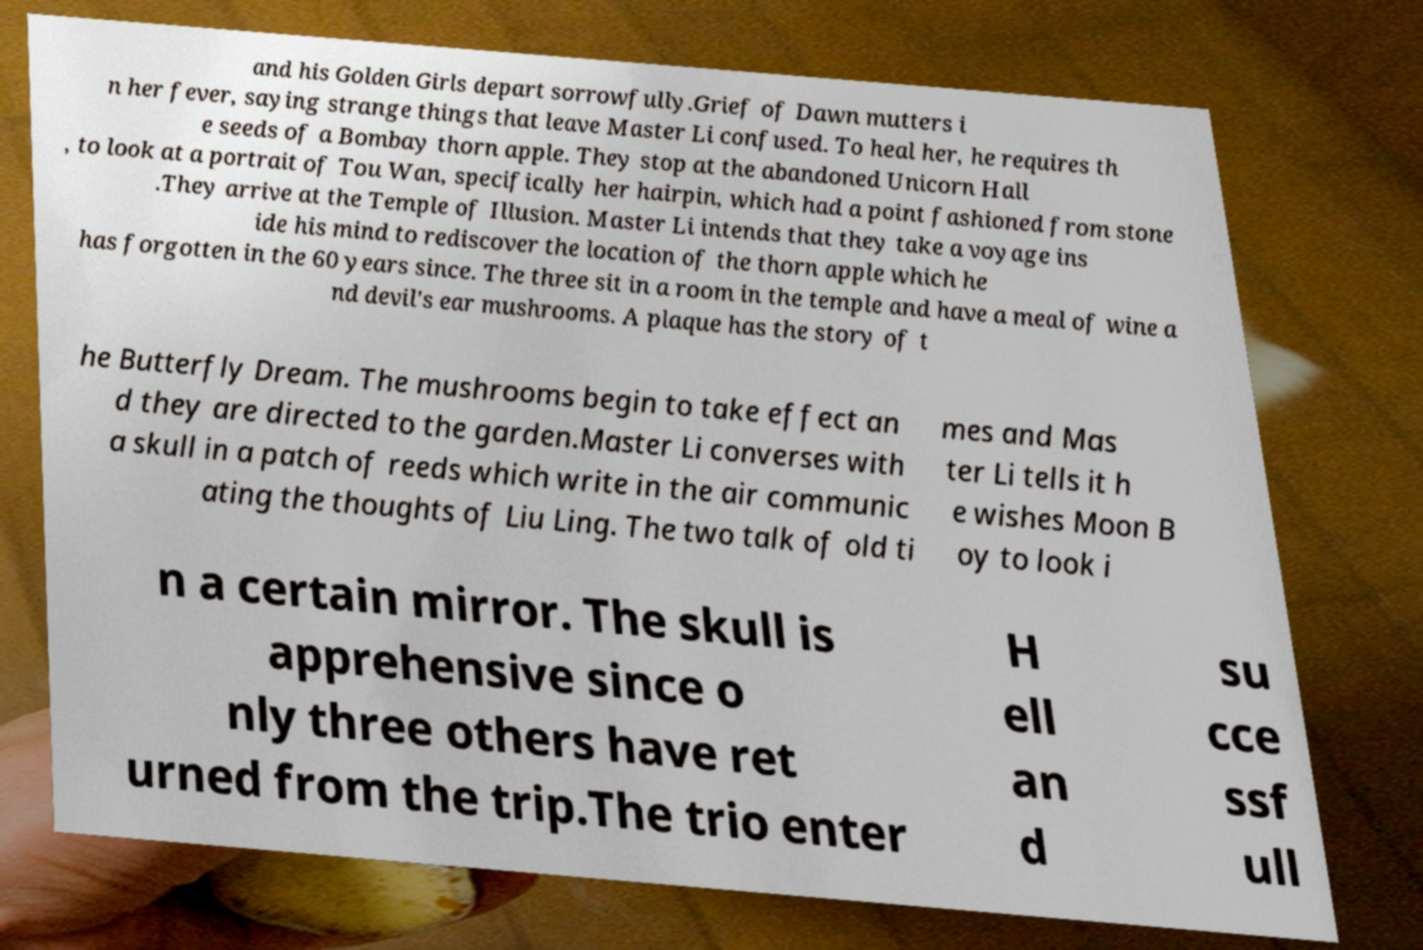What messages or text are displayed in this image? I need them in a readable, typed format. and his Golden Girls depart sorrowfully.Grief of Dawn mutters i n her fever, saying strange things that leave Master Li confused. To heal her, he requires th e seeds of a Bombay thorn apple. They stop at the abandoned Unicorn Hall , to look at a portrait of Tou Wan, specifically her hairpin, which had a point fashioned from stone .They arrive at the Temple of Illusion. Master Li intends that they take a voyage ins ide his mind to rediscover the location of the thorn apple which he has forgotten in the 60 years since. The three sit in a room in the temple and have a meal of wine a nd devil's ear mushrooms. A plaque has the story of t he Butterfly Dream. The mushrooms begin to take effect an d they are directed to the garden.Master Li converses with a skull in a patch of reeds which write in the air communic ating the thoughts of Liu Ling. The two talk of old ti mes and Mas ter Li tells it h e wishes Moon B oy to look i n a certain mirror. The skull is apprehensive since o nly three others have ret urned from the trip.The trio enter H ell an d su cce ssf ull 